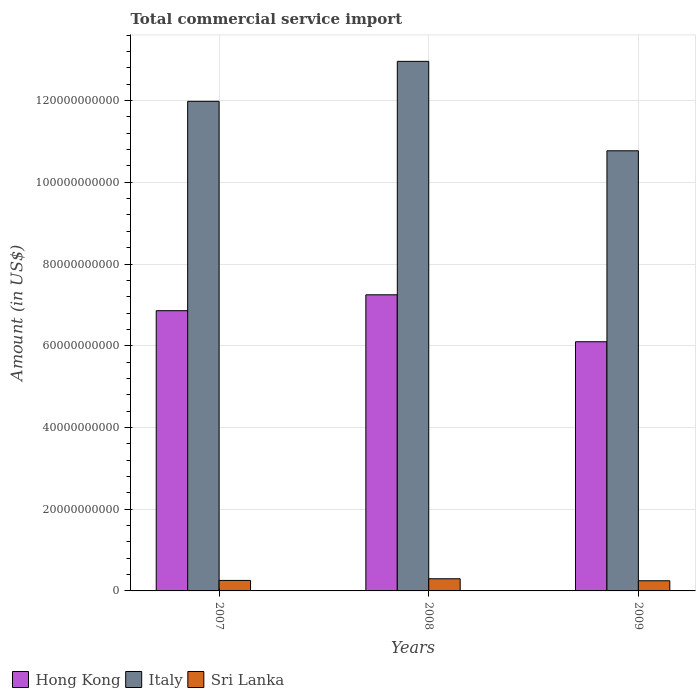How many different coloured bars are there?
Offer a terse response. 3. Are the number of bars on each tick of the X-axis equal?
Your response must be concise. Yes. What is the total commercial service import in Sri Lanka in 2008?
Provide a succinct answer. 2.98e+09. Across all years, what is the maximum total commercial service import in Hong Kong?
Keep it short and to the point. 7.25e+1. Across all years, what is the minimum total commercial service import in Sri Lanka?
Give a very brief answer. 2.49e+09. In which year was the total commercial service import in Sri Lanka minimum?
Make the answer very short. 2009. What is the total total commercial service import in Italy in the graph?
Offer a terse response. 3.57e+11. What is the difference between the total commercial service import in Italy in 2008 and that in 2009?
Provide a succinct answer. 2.19e+1. What is the difference between the total commercial service import in Italy in 2007 and the total commercial service import in Hong Kong in 2008?
Keep it short and to the point. 4.74e+1. What is the average total commercial service import in Italy per year?
Make the answer very short. 1.19e+11. In the year 2007, what is the difference between the total commercial service import in Hong Kong and total commercial service import in Sri Lanka?
Your response must be concise. 6.60e+1. In how many years, is the total commercial service import in Italy greater than 16000000000 US$?
Make the answer very short. 3. What is the ratio of the total commercial service import in Italy in 2007 to that in 2009?
Your response must be concise. 1.11. Is the total commercial service import in Hong Kong in 2007 less than that in 2009?
Give a very brief answer. No. What is the difference between the highest and the second highest total commercial service import in Italy?
Offer a terse response. 9.78e+09. What is the difference between the highest and the lowest total commercial service import in Sri Lanka?
Ensure brevity in your answer.  4.88e+08. In how many years, is the total commercial service import in Hong Kong greater than the average total commercial service import in Hong Kong taken over all years?
Ensure brevity in your answer.  2. What does the 1st bar from the left in 2008 represents?
Offer a terse response. Hong Kong. What does the 2nd bar from the right in 2009 represents?
Offer a terse response. Italy. Is it the case that in every year, the sum of the total commercial service import in Italy and total commercial service import in Hong Kong is greater than the total commercial service import in Sri Lanka?
Your answer should be compact. Yes. How many bars are there?
Provide a short and direct response. 9. Are all the bars in the graph horizontal?
Offer a terse response. No. How many years are there in the graph?
Make the answer very short. 3. What is the difference between two consecutive major ticks on the Y-axis?
Give a very brief answer. 2.00e+1. Does the graph contain grids?
Offer a terse response. Yes. How many legend labels are there?
Keep it short and to the point. 3. How are the legend labels stacked?
Offer a terse response. Horizontal. What is the title of the graph?
Your answer should be very brief. Total commercial service import. What is the label or title of the Y-axis?
Ensure brevity in your answer.  Amount (in US$). What is the Amount (in US$) in Hong Kong in 2007?
Give a very brief answer. 6.86e+1. What is the Amount (in US$) of Italy in 2007?
Your answer should be compact. 1.20e+11. What is the Amount (in US$) of Sri Lanka in 2007?
Give a very brief answer. 2.57e+09. What is the Amount (in US$) of Hong Kong in 2008?
Give a very brief answer. 7.25e+1. What is the Amount (in US$) of Italy in 2008?
Give a very brief answer. 1.30e+11. What is the Amount (in US$) of Sri Lanka in 2008?
Offer a very short reply. 2.98e+09. What is the Amount (in US$) of Hong Kong in 2009?
Offer a terse response. 6.10e+1. What is the Amount (in US$) of Italy in 2009?
Ensure brevity in your answer.  1.08e+11. What is the Amount (in US$) in Sri Lanka in 2009?
Provide a short and direct response. 2.49e+09. Across all years, what is the maximum Amount (in US$) in Hong Kong?
Offer a terse response. 7.25e+1. Across all years, what is the maximum Amount (in US$) of Italy?
Your answer should be very brief. 1.30e+11. Across all years, what is the maximum Amount (in US$) in Sri Lanka?
Provide a succinct answer. 2.98e+09. Across all years, what is the minimum Amount (in US$) of Hong Kong?
Keep it short and to the point. 6.10e+1. Across all years, what is the minimum Amount (in US$) in Italy?
Offer a terse response. 1.08e+11. Across all years, what is the minimum Amount (in US$) in Sri Lanka?
Provide a short and direct response. 2.49e+09. What is the total Amount (in US$) in Hong Kong in the graph?
Ensure brevity in your answer.  2.02e+11. What is the total Amount (in US$) in Italy in the graph?
Give a very brief answer. 3.57e+11. What is the total Amount (in US$) in Sri Lanka in the graph?
Your answer should be compact. 8.03e+09. What is the difference between the Amount (in US$) in Hong Kong in 2007 and that in 2008?
Ensure brevity in your answer.  -3.89e+09. What is the difference between the Amount (in US$) in Italy in 2007 and that in 2008?
Provide a succinct answer. -9.78e+09. What is the difference between the Amount (in US$) in Sri Lanka in 2007 and that in 2008?
Your answer should be compact. -4.07e+08. What is the difference between the Amount (in US$) of Hong Kong in 2007 and that in 2009?
Provide a succinct answer. 7.60e+09. What is the difference between the Amount (in US$) of Italy in 2007 and that in 2009?
Keep it short and to the point. 1.21e+1. What is the difference between the Amount (in US$) of Sri Lanka in 2007 and that in 2009?
Your answer should be very brief. 8.02e+07. What is the difference between the Amount (in US$) of Hong Kong in 2008 and that in 2009?
Ensure brevity in your answer.  1.15e+1. What is the difference between the Amount (in US$) of Italy in 2008 and that in 2009?
Give a very brief answer. 2.19e+1. What is the difference between the Amount (in US$) in Sri Lanka in 2008 and that in 2009?
Give a very brief answer. 4.88e+08. What is the difference between the Amount (in US$) in Hong Kong in 2007 and the Amount (in US$) in Italy in 2008?
Provide a short and direct response. -6.10e+1. What is the difference between the Amount (in US$) of Hong Kong in 2007 and the Amount (in US$) of Sri Lanka in 2008?
Offer a terse response. 6.56e+1. What is the difference between the Amount (in US$) in Italy in 2007 and the Amount (in US$) in Sri Lanka in 2008?
Offer a very short reply. 1.17e+11. What is the difference between the Amount (in US$) in Hong Kong in 2007 and the Amount (in US$) in Italy in 2009?
Your answer should be compact. -3.91e+1. What is the difference between the Amount (in US$) of Hong Kong in 2007 and the Amount (in US$) of Sri Lanka in 2009?
Your answer should be compact. 6.61e+1. What is the difference between the Amount (in US$) in Italy in 2007 and the Amount (in US$) in Sri Lanka in 2009?
Your response must be concise. 1.17e+11. What is the difference between the Amount (in US$) in Hong Kong in 2008 and the Amount (in US$) in Italy in 2009?
Provide a short and direct response. -3.52e+1. What is the difference between the Amount (in US$) of Hong Kong in 2008 and the Amount (in US$) of Sri Lanka in 2009?
Make the answer very short. 7.00e+1. What is the difference between the Amount (in US$) of Italy in 2008 and the Amount (in US$) of Sri Lanka in 2009?
Your answer should be very brief. 1.27e+11. What is the average Amount (in US$) in Hong Kong per year?
Give a very brief answer. 6.73e+1. What is the average Amount (in US$) of Italy per year?
Your response must be concise. 1.19e+11. What is the average Amount (in US$) of Sri Lanka per year?
Offer a terse response. 2.68e+09. In the year 2007, what is the difference between the Amount (in US$) of Hong Kong and Amount (in US$) of Italy?
Keep it short and to the point. -5.12e+1. In the year 2007, what is the difference between the Amount (in US$) in Hong Kong and Amount (in US$) in Sri Lanka?
Keep it short and to the point. 6.60e+1. In the year 2007, what is the difference between the Amount (in US$) of Italy and Amount (in US$) of Sri Lanka?
Your answer should be compact. 1.17e+11. In the year 2008, what is the difference between the Amount (in US$) of Hong Kong and Amount (in US$) of Italy?
Provide a short and direct response. -5.71e+1. In the year 2008, what is the difference between the Amount (in US$) in Hong Kong and Amount (in US$) in Sri Lanka?
Provide a succinct answer. 6.95e+1. In the year 2008, what is the difference between the Amount (in US$) of Italy and Amount (in US$) of Sri Lanka?
Make the answer very short. 1.27e+11. In the year 2009, what is the difference between the Amount (in US$) in Hong Kong and Amount (in US$) in Italy?
Your answer should be very brief. -4.67e+1. In the year 2009, what is the difference between the Amount (in US$) in Hong Kong and Amount (in US$) in Sri Lanka?
Your response must be concise. 5.85e+1. In the year 2009, what is the difference between the Amount (in US$) in Italy and Amount (in US$) in Sri Lanka?
Provide a short and direct response. 1.05e+11. What is the ratio of the Amount (in US$) in Hong Kong in 2007 to that in 2008?
Ensure brevity in your answer.  0.95. What is the ratio of the Amount (in US$) in Italy in 2007 to that in 2008?
Keep it short and to the point. 0.92. What is the ratio of the Amount (in US$) of Sri Lanka in 2007 to that in 2008?
Offer a very short reply. 0.86. What is the ratio of the Amount (in US$) in Hong Kong in 2007 to that in 2009?
Ensure brevity in your answer.  1.12. What is the ratio of the Amount (in US$) in Italy in 2007 to that in 2009?
Your response must be concise. 1.11. What is the ratio of the Amount (in US$) in Sri Lanka in 2007 to that in 2009?
Provide a short and direct response. 1.03. What is the ratio of the Amount (in US$) of Hong Kong in 2008 to that in 2009?
Provide a succinct answer. 1.19. What is the ratio of the Amount (in US$) in Italy in 2008 to that in 2009?
Offer a terse response. 1.2. What is the ratio of the Amount (in US$) in Sri Lanka in 2008 to that in 2009?
Provide a succinct answer. 1.2. What is the difference between the highest and the second highest Amount (in US$) of Hong Kong?
Provide a succinct answer. 3.89e+09. What is the difference between the highest and the second highest Amount (in US$) of Italy?
Your answer should be very brief. 9.78e+09. What is the difference between the highest and the second highest Amount (in US$) of Sri Lanka?
Offer a very short reply. 4.07e+08. What is the difference between the highest and the lowest Amount (in US$) of Hong Kong?
Keep it short and to the point. 1.15e+1. What is the difference between the highest and the lowest Amount (in US$) in Italy?
Offer a terse response. 2.19e+1. What is the difference between the highest and the lowest Amount (in US$) in Sri Lanka?
Keep it short and to the point. 4.88e+08. 